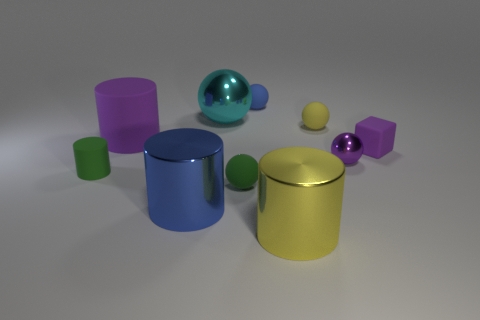Is there anything else of the same color as the small cube?
Ensure brevity in your answer.  Yes. What shape is the other matte object that is the same color as the big matte thing?
Make the answer very short. Cube. There is a matte cylinder that is the same size as the blue metal thing; what is its color?
Offer a terse response. Purple. How many blue balls are there?
Ensure brevity in your answer.  1. Do the yellow object that is behind the large yellow cylinder and the tiny blue ball have the same material?
Offer a terse response. Yes. There is a large cylinder that is both left of the large ball and in front of the purple metallic sphere; what is its material?
Offer a very short reply. Metal. There is a matte cylinder that is the same color as the small metal object; what is its size?
Keep it short and to the point. Large. There is a purple thing left of the small yellow ball in front of the cyan ball; what is it made of?
Make the answer very short. Rubber. There is a purple matte thing that is left of the blue thing that is behind the blue thing that is in front of the blue matte sphere; how big is it?
Make the answer very short. Large. What number of objects have the same material as the large yellow cylinder?
Offer a terse response. 3. 